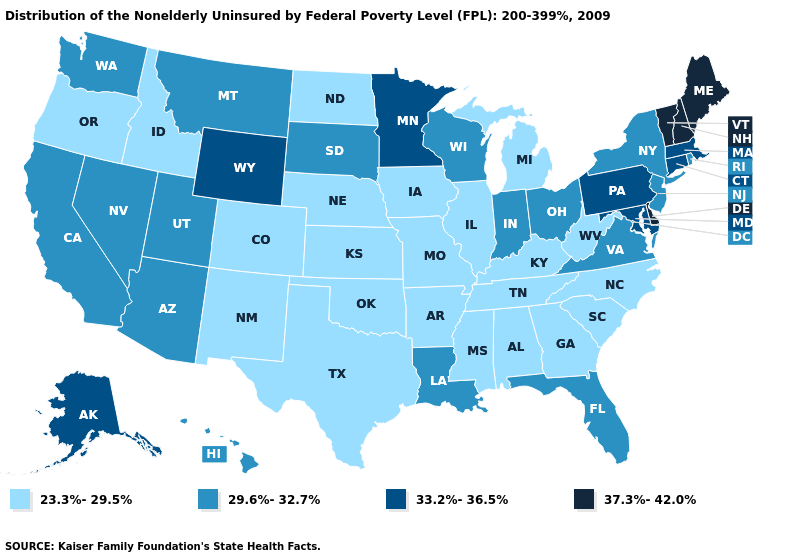Which states hav the highest value in the West?
Answer briefly. Alaska, Wyoming. Name the states that have a value in the range 23.3%-29.5%?
Concise answer only. Alabama, Arkansas, Colorado, Georgia, Idaho, Illinois, Iowa, Kansas, Kentucky, Michigan, Mississippi, Missouri, Nebraska, New Mexico, North Carolina, North Dakota, Oklahoma, Oregon, South Carolina, Tennessee, Texas, West Virginia. Does Louisiana have a higher value than West Virginia?
Give a very brief answer. Yes. What is the value of Michigan?
Answer briefly. 23.3%-29.5%. Name the states that have a value in the range 33.2%-36.5%?
Give a very brief answer. Alaska, Connecticut, Maryland, Massachusetts, Minnesota, Pennsylvania, Wyoming. Does Ohio have a lower value than Delaware?
Be succinct. Yes. Among the states that border North Dakota , does Minnesota have the highest value?
Be succinct. Yes. Name the states that have a value in the range 33.2%-36.5%?
Short answer required. Alaska, Connecticut, Maryland, Massachusetts, Minnesota, Pennsylvania, Wyoming. Among the states that border Pennsylvania , which have the lowest value?
Write a very short answer. West Virginia. What is the lowest value in states that border California?
Write a very short answer. 23.3%-29.5%. How many symbols are there in the legend?
Write a very short answer. 4. Does Nebraska have the highest value in the USA?
Concise answer only. No. Does Arkansas have the highest value in the South?
Answer briefly. No. Name the states that have a value in the range 37.3%-42.0%?
Short answer required. Delaware, Maine, New Hampshire, Vermont. 